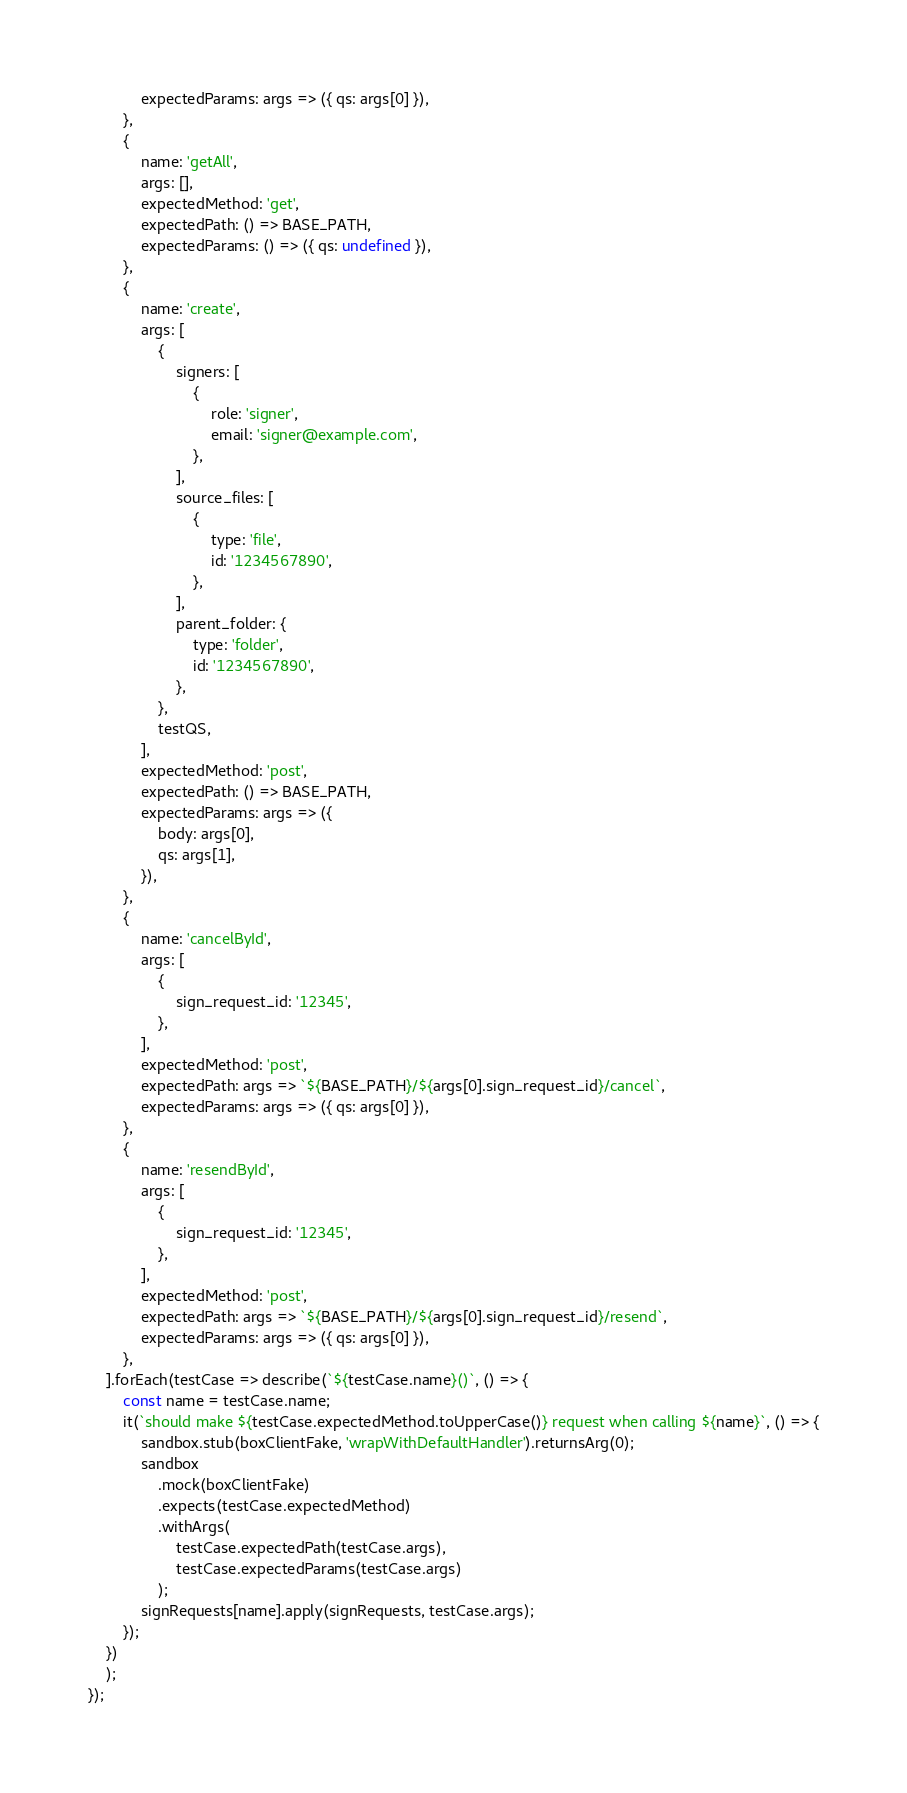<code> <loc_0><loc_0><loc_500><loc_500><_JavaScript_>			expectedParams: args => ({ qs: args[0] }),
		},
		{
			name: 'getAll',
			args: [],
			expectedMethod: 'get',
			expectedPath: () => BASE_PATH,
			expectedParams: () => ({ qs: undefined }),
		},
		{
			name: 'create',
			args: [
				{
					signers: [
						{
							role: 'signer',
							email: 'signer@example.com',
						},
					],
					source_files: [
						{
							type: 'file',
							id: '1234567890',
						},
					],
					parent_folder: {
						type: 'folder',
						id: '1234567890',
					},
				},
				testQS,
			],
			expectedMethod: 'post',
			expectedPath: () => BASE_PATH,
			expectedParams: args => ({
				body: args[0],
				qs: args[1],
			}),
		},
		{
			name: 'cancelById',
			args: [
				{
					sign_request_id: '12345',
				},
			],
			expectedMethod: 'post',
			expectedPath: args => `${BASE_PATH}/${args[0].sign_request_id}/cancel`,
			expectedParams: args => ({ qs: args[0] }),
		},
		{
			name: 'resendById',
			args: [
				{
					sign_request_id: '12345',
				},
			],
			expectedMethod: 'post',
			expectedPath: args => `${BASE_PATH}/${args[0].sign_request_id}/resend`,
			expectedParams: args => ({ qs: args[0] }),
		},
	].forEach(testCase => describe(`${testCase.name}()`, () => {
		const name = testCase.name;
		it(`should make ${testCase.expectedMethod.toUpperCase()} request when calling ${name}`, () => {
			sandbox.stub(boxClientFake, 'wrapWithDefaultHandler').returnsArg(0);
			sandbox
				.mock(boxClientFake)
				.expects(testCase.expectedMethod)
				.withArgs(
					testCase.expectedPath(testCase.args),
					testCase.expectedParams(testCase.args)
				);
			signRequests[name].apply(signRequests, testCase.args);
		});
	})
	);
});
</code> 